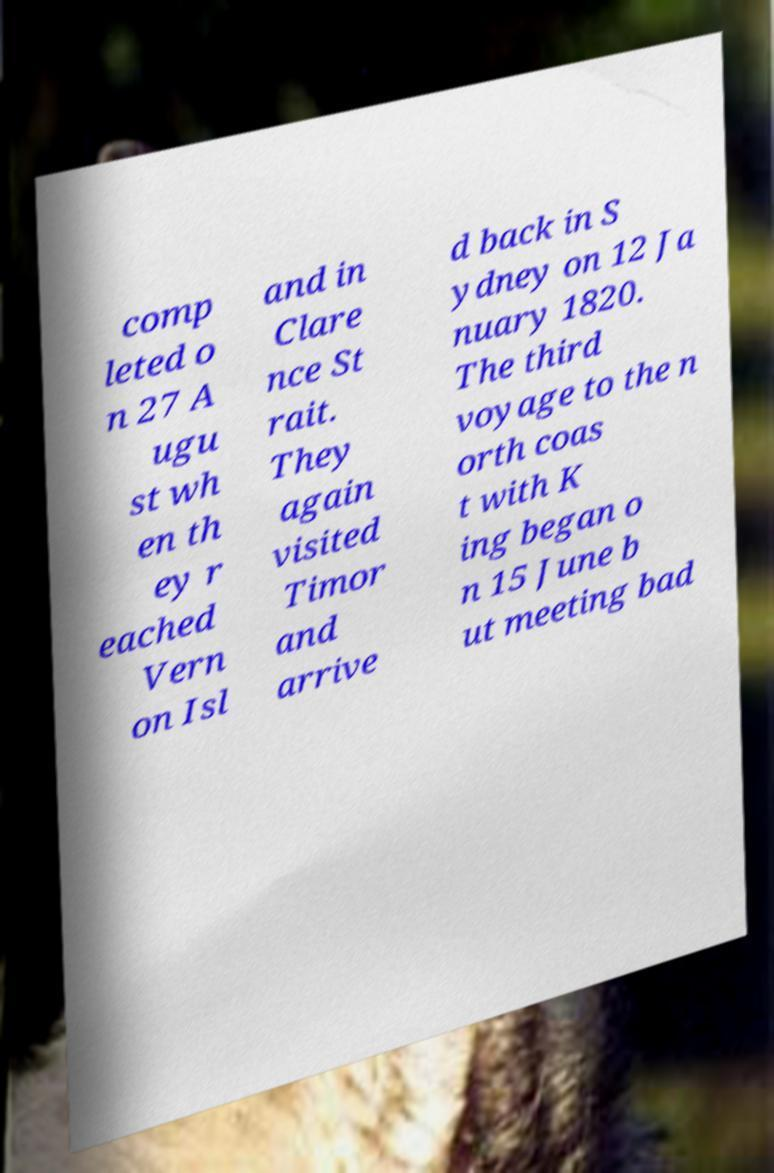I need the written content from this picture converted into text. Can you do that? comp leted o n 27 A ugu st wh en th ey r eached Vern on Isl and in Clare nce St rait. They again visited Timor and arrive d back in S ydney on 12 Ja nuary 1820. The third voyage to the n orth coas t with K ing began o n 15 June b ut meeting bad 